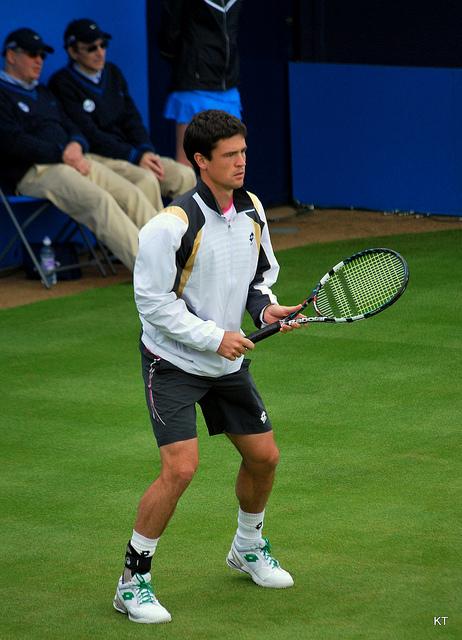What type is the surface?
Be succinct. Grass. What is on his wrist?
Keep it brief. Nothing. What color is the ladies jacket?
Give a very brief answer. White. What sport is he playing?
Answer briefly. Tennis. What sport is this?
Short answer required. Tennis. What color are the strings on the man's racket?
Write a very short answer. White. What is on the man's ankle?
Keep it brief. Brace. What is the man about to do?
Answer briefly. Tennis. 